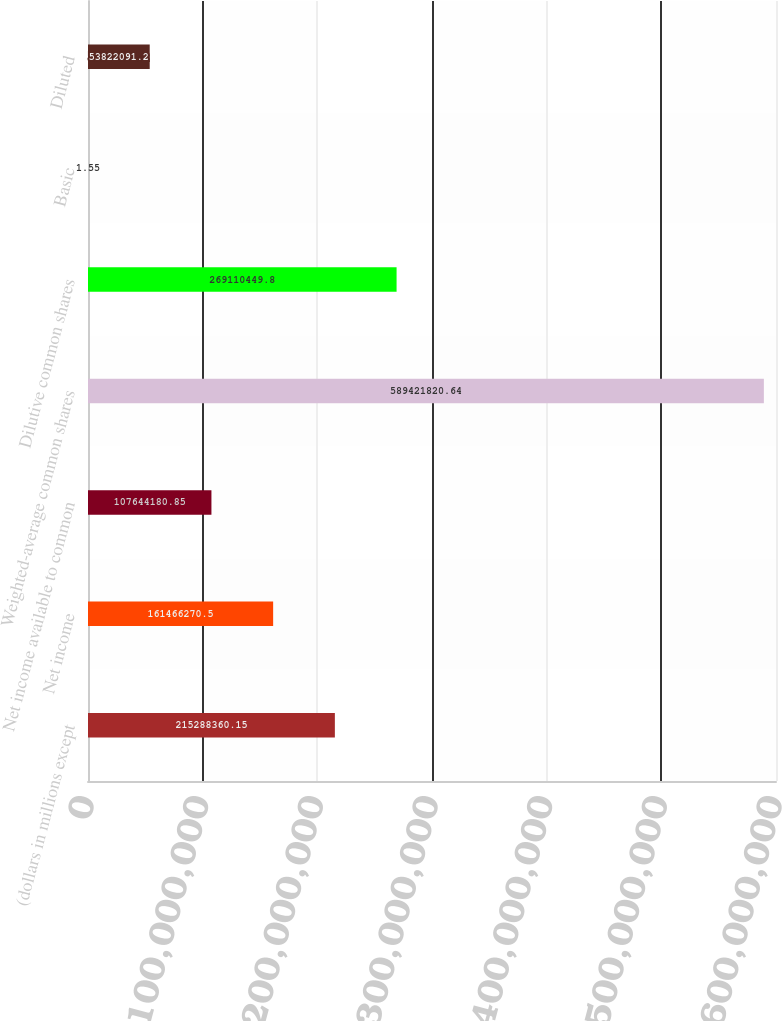<chart> <loc_0><loc_0><loc_500><loc_500><bar_chart><fcel>(dollars in millions except<fcel>Net income<fcel>Net income available to common<fcel>Weighted-average common shares<fcel>Dilutive common shares<fcel>Basic<fcel>Diluted<nl><fcel>2.15288e+08<fcel>1.61466e+08<fcel>1.07644e+08<fcel>5.89422e+08<fcel>2.6911e+08<fcel>1.55<fcel>5.38221e+07<nl></chart> 